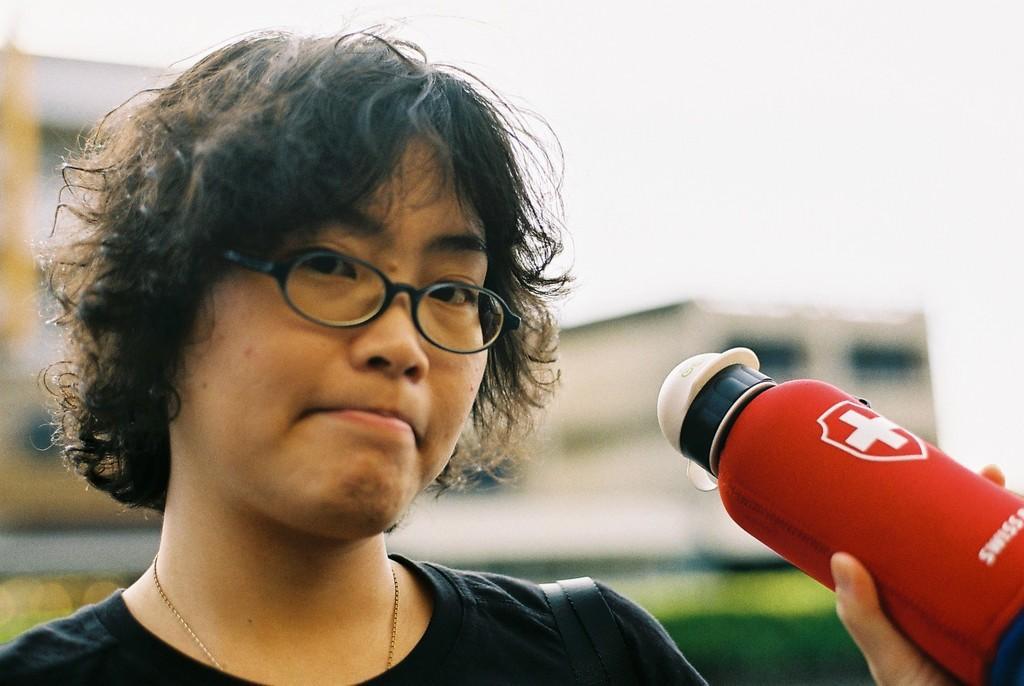In one or two sentences, can you explain what this image depicts? In this image I can see a woman and I can see she is holding a red colour bottle. I can see she is wearing specs, black t shirt and on this bottle I can see something is written. I can also see this image is little bit blurry from background. 